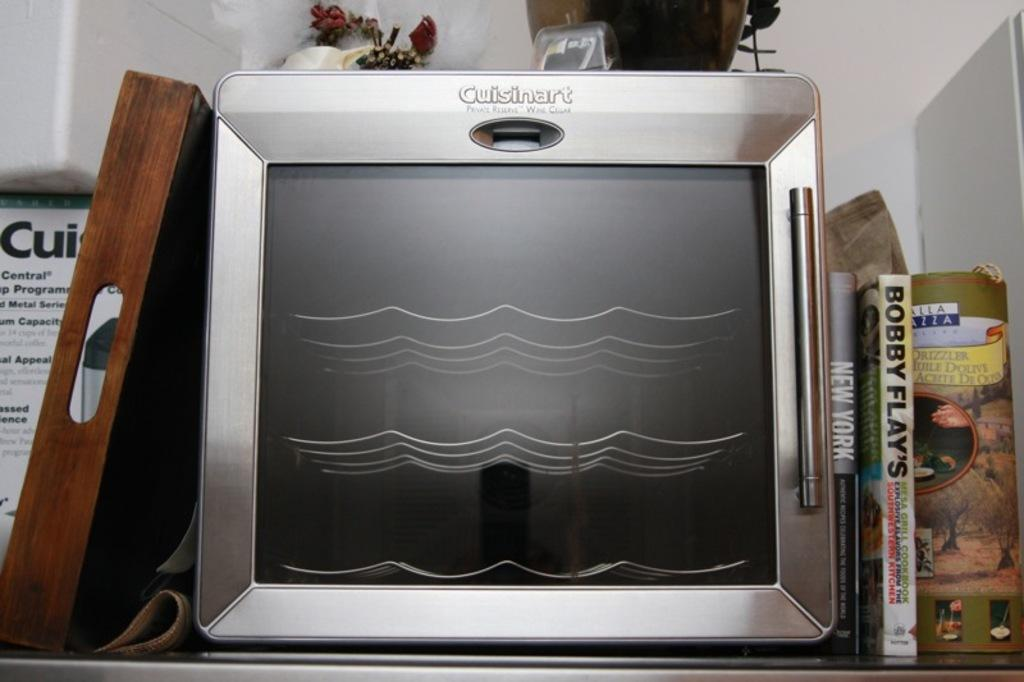<image>
Share a concise interpretation of the image provided. Bobby Flay's reads the spine of the book next to the toaster oven. 